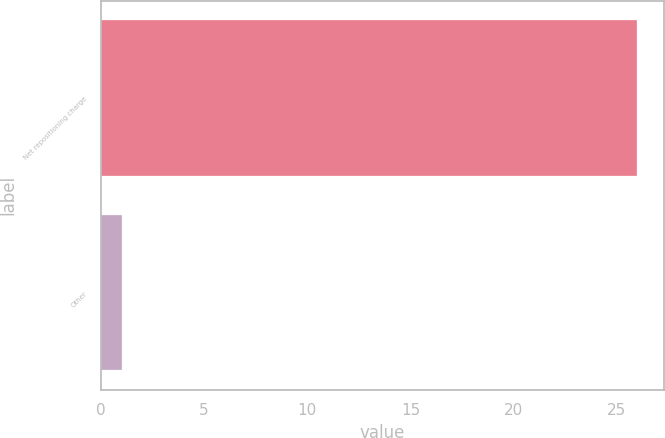<chart> <loc_0><loc_0><loc_500><loc_500><bar_chart><fcel>Net repositioning charge<fcel>Other<nl><fcel>26<fcel>1<nl></chart> 